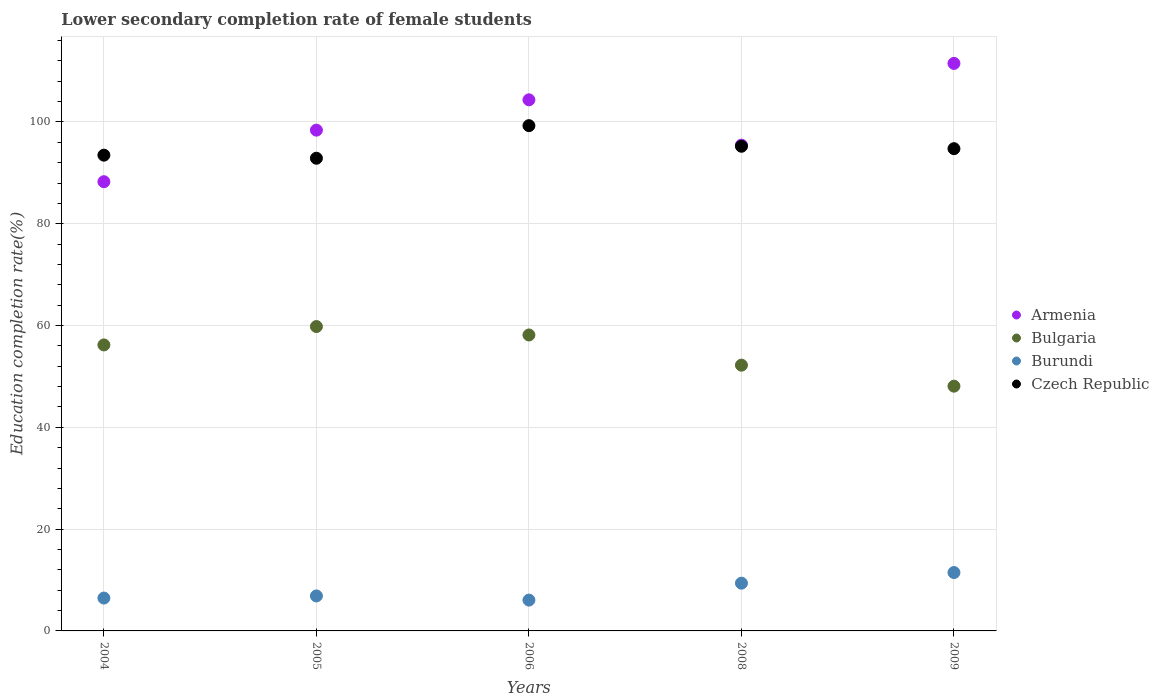What is the lower secondary completion rate of female students in Armenia in 2008?
Offer a very short reply. 95.44. Across all years, what is the maximum lower secondary completion rate of female students in Bulgaria?
Offer a very short reply. 59.8. Across all years, what is the minimum lower secondary completion rate of female students in Armenia?
Give a very brief answer. 88.26. In which year was the lower secondary completion rate of female students in Bulgaria maximum?
Keep it short and to the point. 2005. In which year was the lower secondary completion rate of female students in Bulgaria minimum?
Your answer should be very brief. 2009. What is the total lower secondary completion rate of female students in Burundi in the graph?
Your answer should be very brief. 40.23. What is the difference between the lower secondary completion rate of female students in Burundi in 2006 and that in 2008?
Your answer should be compact. -3.32. What is the difference between the lower secondary completion rate of female students in Burundi in 2006 and the lower secondary completion rate of female students in Czech Republic in 2009?
Your answer should be compact. -88.69. What is the average lower secondary completion rate of female students in Bulgaria per year?
Offer a terse response. 54.89. In the year 2005, what is the difference between the lower secondary completion rate of female students in Czech Republic and lower secondary completion rate of female students in Armenia?
Your answer should be compact. -5.52. What is the ratio of the lower secondary completion rate of female students in Bulgaria in 2004 to that in 2009?
Offer a very short reply. 1.17. Is the lower secondary completion rate of female students in Burundi in 2006 less than that in 2008?
Ensure brevity in your answer.  Yes. What is the difference between the highest and the second highest lower secondary completion rate of female students in Bulgaria?
Your answer should be very brief. 1.65. What is the difference between the highest and the lowest lower secondary completion rate of female students in Czech Republic?
Offer a terse response. 6.4. In how many years, is the lower secondary completion rate of female students in Burundi greater than the average lower secondary completion rate of female students in Burundi taken over all years?
Your answer should be compact. 2. Is it the case that in every year, the sum of the lower secondary completion rate of female students in Bulgaria and lower secondary completion rate of female students in Armenia  is greater than the lower secondary completion rate of female students in Burundi?
Ensure brevity in your answer.  Yes. Does the graph contain grids?
Provide a short and direct response. Yes. Where does the legend appear in the graph?
Offer a very short reply. Center right. What is the title of the graph?
Your response must be concise. Lower secondary completion rate of female students. Does "Dominica" appear as one of the legend labels in the graph?
Provide a short and direct response. No. What is the label or title of the X-axis?
Give a very brief answer. Years. What is the label or title of the Y-axis?
Offer a terse response. Education completion rate(%). What is the Education completion rate(%) of Armenia in 2004?
Ensure brevity in your answer.  88.26. What is the Education completion rate(%) of Bulgaria in 2004?
Provide a succinct answer. 56.19. What is the Education completion rate(%) of Burundi in 2004?
Keep it short and to the point. 6.45. What is the Education completion rate(%) in Czech Republic in 2004?
Provide a succinct answer. 93.48. What is the Education completion rate(%) in Armenia in 2005?
Your answer should be very brief. 98.39. What is the Education completion rate(%) in Bulgaria in 2005?
Give a very brief answer. 59.8. What is the Education completion rate(%) in Burundi in 2005?
Keep it short and to the point. 6.87. What is the Education completion rate(%) of Czech Republic in 2005?
Provide a short and direct response. 92.87. What is the Education completion rate(%) of Armenia in 2006?
Provide a short and direct response. 104.35. What is the Education completion rate(%) in Bulgaria in 2006?
Offer a terse response. 58.14. What is the Education completion rate(%) in Burundi in 2006?
Offer a terse response. 6.06. What is the Education completion rate(%) of Czech Republic in 2006?
Your answer should be very brief. 99.27. What is the Education completion rate(%) of Armenia in 2008?
Provide a short and direct response. 95.44. What is the Education completion rate(%) of Bulgaria in 2008?
Your answer should be compact. 52.21. What is the Education completion rate(%) in Burundi in 2008?
Make the answer very short. 9.38. What is the Education completion rate(%) of Czech Republic in 2008?
Offer a terse response. 95.22. What is the Education completion rate(%) of Armenia in 2009?
Offer a very short reply. 111.5. What is the Education completion rate(%) of Bulgaria in 2009?
Offer a very short reply. 48.09. What is the Education completion rate(%) of Burundi in 2009?
Make the answer very short. 11.47. What is the Education completion rate(%) of Czech Republic in 2009?
Your answer should be compact. 94.75. Across all years, what is the maximum Education completion rate(%) of Armenia?
Offer a terse response. 111.5. Across all years, what is the maximum Education completion rate(%) of Bulgaria?
Your response must be concise. 59.8. Across all years, what is the maximum Education completion rate(%) of Burundi?
Your answer should be compact. 11.47. Across all years, what is the maximum Education completion rate(%) of Czech Republic?
Give a very brief answer. 99.27. Across all years, what is the minimum Education completion rate(%) in Armenia?
Provide a succinct answer. 88.26. Across all years, what is the minimum Education completion rate(%) of Bulgaria?
Give a very brief answer. 48.09. Across all years, what is the minimum Education completion rate(%) in Burundi?
Provide a short and direct response. 6.06. Across all years, what is the minimum Education completion rate(%) of Czech Republic?
Ensure brevity in your answer.  92.87. What is the total Education completion rate(%) of Armenia in the graph?
Your response must be concise. 497.93. What is the total Education completion rate(%) in Bulgaria in the graph?
Your answer should be compact. 274.43. What is the total Education completion rate(%) of Burundi in the graph?
Ensure brevity in your answer.  40.23. What is the total Education completion rate(%) in Czech Republic in the graph?
Keep it short and to the point. 475.59. What is the difference between the Education completion rate(%) in Armenia in 2004 and that in 2005?
Provide a short and direct response. -10.13. What is the difference between the Education completion rate(%) of Bulgaria in 2004 and that in 2005?
Ensure brevity in your answer.  -3.61. What is the difference between the Education completion rate(%) in Burundi in 2004 and that in 2005?
Make the answer very short. -0.42. What is the difference between the Education completion rate(%) in Czech Republic in 2004 and that in 2005?
Offer a terse response. 0.61. What is the difference between the Education completion rate(%) in Armenia in 2004 and that in 2006?
Give a very brief answer. -16.09. What is the difference between the Education completion rate(%) of Bulgaria in 2004 and that in 2006?
Provide a succinct answer. -1.96. What is the difference between the Education completion rate(%) of Burundi in 2004 and that in 2006?
Provide a succinct answer. 0.4. What is the difference between the Education completion rate(%) of Czech Republic in 2004 and that in 2006?
Your answer should be very brief. -5.8. What is the difference between the Education completion rate(%) in Armenia in 2004 and that in 2008?
Keep it short and to the point. -7.18. What is the difference between the Education completion rate(%) of Bulgaria in 2004 and that in 2008?
Ensure brevity in your answer.  3.97. What is the difference between the Education completion rate(%) in Burundi in 2004 and that in 2008?
Your answer should be compact. -2.92. What is the difference between the Education completion rate(%) of Czech Republic in 2004 and that in 2008?
Offer a very short reply. -1.75. What is the difference between the Education completion rate(%) of Armenia in 2004 and that in 2009?
Offer a terse response. -23.24. What is the difference between the Education completion rate(%) in Bulgaria in 2004 and that in 2009?
Give a very brief answer. 8.1. What is the difference between the Education completion rate(%) of Burundi in 2004 and that in 2009?
Your response must be concise. -5.02. What is the difference between the Education completion rate(%) of Czech Republic in 2004 and that in 2009?
Offer a terse response. -1.27. What is the difference between the Education completion rate(%) in Armenia in 2005 and that in 2006?
Offer a terse response. -5.96. What is the difference between the Education completion rate(%) in Bulgaria in 2005 and that in 2006?
Provide a short and direct response. 1.65. What is the difference between the Education completion rate(%) of Burundi in 2005 and that in 2006?
Offer a terse response. 0.82. What is the difference between the Education completion rate(%) in Czech Republic in 2005 and that in 2006?
Provide a short and direct response. -6.4. What is the difference between the Education completion rate(%) of Armenia in 2005 and that in 2008?
Your response must be concise. 2.95. What is the difference between the Education completion rate(%) in Bulgaria in 2005 and that in 2008?
Ensure brevity in your answer.  7.58. What is the difference between the Education completion rate(%) in Burundi in 2005 and that in 2008?
Keep it short and to the point. -2.5. What is the difference between the Education completion rate(%) in Czech Republic in 2005 and that in 2008?
Your answer should be compact. -2.35. What is the difference between the Education completion rate(%) in Armenia in 2005 and that in 2009?
Your answer should be compact. -13.11. What is the difference between the Education completion rate(%) in Bulgaria in 2005 and that in 2009?
Make the answer very short. 11.71. What is the difference between the Education completion rate(%) of Burundi in 2005 and that in 2009?
Your answer should be very brief. -4.6. What is the difference between the Education completion rate(%) in Czech Republic in 2005 and that in 2009?
Offer a terse response. -1.88. What is the difference between the Education completion rate(%) of Armenia in 2006 and that in 2008?
Provide a succinct answer. 8.9. What is the difference between the Education completion rate(%) of Bulgaria in 2006 and that in 2008?
Offer a very short reply. 5.93. What is the difference between the Education completion rate(%) in Burundi in 2006 and that in 2008?
Make the answer very short. -3.32. What is the difference between the Education completion rate(%) in Czech Republic in 2006 and that in 2008?
Ensure brevity in your answer.  4.05. What is the difference between the Education completion rate(%) in Armenia in 2006 and that in 2009?
Your answer should be very brief. -7.15. What is the difference between the Education completion rate(%) in Bulgaria in 2006 and that in 2009?
Provide a short and direct response. 10.06. What is the difference between the Education completion rate(%) in Burundi in 2006 and that in 2009?
Give a very brief answer. -5.41. What is the difference between the Education completion rate(%) of Czech Republic in 2006 and that in 2009?
Offer a very short reply. 4.52. What is the difference between the Education completion rate(%) of Armenia in 2008 and that in 2009?
Ensure brevity in your answer.  -16.06. What is the difference between the Education completion rate(%) of Bulgaria in 2008 and that in 2009?
Your answer should be compact. 4.13. What is the difference between the Education completion rate(%) of Burundi in 2008 and that in 2009?
Offer a terse response. -2.09. What is the difference between the Education completion rate(%) in Czech Republic in 2008 and that in 2009?
Keep it short and to the point. 0.47. What is the difference between the Education completion rate(%) in Armenia in 2004 and the Education completion rate(%) in Bulgaria in 2005?
Your answer should be compact. 28.46. What is the difference between the Education completion rate(%) of Armenia in 2004 and the Education completion rate(%) of Burundi in 2005?
Your response must be concise. 81.38. What is the difference between the Education completion rate(%) of Armenia in 2004 and the Education completion rate(%) of Czech Republic in 2005?
Offer a terse response. -4.61. What is the difference between the Education completion rate(%) in Bulgaria in 2004 and the Education completion rate(%) in Burundi in 2005?
Offer a very short reply. 49.32. What is the difference between the Education completion rate(%) in Bulgaria in 2004 and the Education completion rate(%) in Czech Republic in 2005?
Your answer should be compact. -36.68. What is the difference between the Education completion rate(%) in Burundi in 2004 and the Education completion rate(%) in Czech Republic in 2005?
Offer a terse response. -86.41. What is the difference between the Education completion rate(%) in Armenia in 2004 and the Education completion rate(%) in Bulgaria in 2006?
Keep it short and to the point. 30.11. What is the difference between the Education completion rate(%) in Armenia in 2004 and the Education completion rate(%) in Burundi in 2006?
Offer a very short reply. 82.2. What is the difference between the Education completion rate(%) of Armenia in 2004 and the Education completion rate(%) of Czech Republic in 2006?
Ensure brevity in your answer.  -11.01. What is the difference between the Education completion rate(%) of Bulgaria in 2004 and the Education completion rate(%) of Burundi in 2006?
Your response must be concise. 50.13. What is the difference between the Education completion rate(%) of Bulgaria in 2004 and the Education completion rate(%) of Czech Republic in 2006?
Offer a very short reply. -43.08. What is the difference between the Education completion rate(%) of Burundi in 2004 and the Education completion rate(%) of Czech Republic in 2006?
Your answer should be very brief. -92.82. What is the difference between the Education completion rate(%) in Armenia in 2004 and the Education completion rate(%) in Bulgaria in 2008?
Keep it short and to the point. 36.04. What is the difference between the Education completion rate(%) in Armenia in 2004 and the Education completion rate(%) in Burundi in 2008?
Ensure brevity in your answer.  78.88. What is the difference between the Education completion rate(%) in Armenia in 2004 and the Education completion rate(%) in Czech Republic in 2008?
Your answer should be compact. -6.96. What is the difference between the Education completion rate(%) in Bulgaria in 2004 and the Education completion rate(%) in Burundi in 2008?
Your response must be concise. 46.81. What is the difference between the Education completion rate(%) of Bulgaria in 2004 and the Education completion rate(%) of Czech Republic in 2008?
Your answer should be compact. -39.03. What is the difference between the Education completion rate(%) in Burundi in 2004 and the Education completion rate(%) in Czech Republic in 2008?
Offer a very short reply. -88.77. What is the difference between the Education completion rate(%) in Armenia in 2004 and the Education completion rate(%) in Bulgaria in 2009?
Your response must be concise. 40.17. What is the difference between the Education completion rate(%) in Armenia in 2004 and the Education completion rate(%) in Burundi in 2009?
Provide a succinct answer. 76.79. What is the difference between the Education completion rate(%) of Armenia in 2004 and the Education completion rate(%) of Czech Republic in 2009?
Provide a short and direct response. -6.49. What is the difference between the Education completion rate(%) in Bulgaria in 2004 and the Education completion rate(%) in Burundi in 2009?
Give a very brief answer. 44.72. What is the difference between the Education completion rate(%) of Bulgaria in 2004 and the Education completion rate(%) of Czech Republic in 2009?
Your answer should be very brief. -38.56. What is the difference between the Education completion rate(%) in Burundi in 2004 and the Education completion rate(%) in Czech Republic in 2009?
Give a very brief answer. -88.29. What is the difference between the Education completion rate(%) of Armenia in 2005 and the Education completion rate(%) of Bulgaria in 2006?
Give a very brief answer. 40.24. What is the difference between the Education completion rate(%) in Armenia in 2005 and the Education completion rate(%) in Burundi in 2006?
Provide a succinct answer. 92.33. What is the difference between the Education completion rate(%) of Armenia in 2005 and the Education completion rate(%) of Czech Republic in 2006?
Provide a short and direct response. -0.88. What is the difference between the Education completion rate(%) in Bulgaria in 2005 and the Education completion rate(%) in Burundi in 2006?
Keep it short and to the point. 53.74. What is the difference between the Education completion rate(%) of Bulgaria in 2005 and the Education completion rate(%) of Czech Republic in 2006?
Offer a very short reply. -39.47. What is the difference between the Education completion rate(%) of Burundi in 2005 and the Education completion rate(%) of Czech Republic in 2006?
Your answer should be compact. -92.4. What is the difference between the Education completion rate(%) of Armenia in 2005 and the Education completion rate(%) of Bulgaria in 2008?
Offer a very short reply. 46.17. What is the difference between the Education completion rate(%) in Armenia in 2005 and the Education completion rate(%) in Burundi in 2008?
Your response must be concise. 89.01. What is the difference between the Education completion rate(%) of Armenia in 2005 and the Education completion rate(%) of Czech Republic in 2008?
Your answer should be compact. 3.16. What is the difference between the Education completion rate(%) in Bulgaria in 2005 and the Education completion rate(%) in Burundi in 2008?
Provide a short and direct response. 50.42. What is the difference between the Education completion rate(%) in Bulgaria in 2005 and the Education completion rate(%) in Czech Republic in 2008?
Give a very brief answer. -35.42. What is the difference between the Education completion rate(%) in Burundi in 2005 and the Education completion rate(%) in Czech Republic in 2008?
Keep it short and to the point. -88.35. What is the difference between the Education completion rate(%) of Armenia in 2005 and the Education completion rate(%) of Bulgaria in 2009?
Give a very brief answer. 50.3. What is the difference between the Education completion rate(%) in Armenia in 2005 and the Education completion rate(%) in Burundi in 2009?
Keep it short and to the point. 86.92. What is the difference between the Education completion rate(%) in Armenia in 2005 and the Education completion rate(%) in Czech Republic in 2009?
Your answer should be very brief. 3.64. What is the difference between the Education completion rate(%) of Bulgaria in 2005 and the Education completion rate(%) of Burundi in 2009?
Give a very brief answer. 48.33. What is the difference between the Education completion rate(%) in Bulgaria in 2005 and the Education completion rate(%) in Czech Republic in 2009?
Offer a very short reply. -34.95. What is the difference between the Education completion rate(%) of Burundi in 2005 and the Education completion rate(%) of Czech Republic in 2009?
Keep it short and to the point. -87.87. What is the difference between the Education completion rate(%) in Armenia in 2006 and the Education completion rate(%) in Bulgaria in 2008?
Offer a terse response. 52.13. What is the difference between the Education completion rate(%) of Armenia in 2006 and the Education completion rate(%) of Burundi in 2008?
Make the answer very short. 94.97. What is the difference between the Education completion rate(%) of Armenia in 2006 and the Education completion rate(%) of Czech Republic in 2008?
Your answer should be compact. 9.12. What is the difference between the Education completion rate(%) of Bulgaria in 2006 and the Education completion rate(%) of Burundi in 2008?
Provide a succinct answer. 48.77. What is the difference between the Education completion rate(%) of Bulgaria in 2006 and the Education completion rate(%) of Czech Republic in 2008?
Your answer should be very brief. -37.08. What is the difference between the Education completion rate(%) in Burundi in 2006 and the Education completion rate(%) in Czech Republic in 2008?
Your answer should be very brief. -89.17. What is the difference between the Education completion rate(%) of Armenia in 2006 and the Education completion rate(%) of Bulgaria in 2009?
Ensure brevity in your answer.  56.26. What is the difference between the Education completion rate(%) in Armenia in 2006 and the Education completion rate(%) in Burundi in 2009?
Make the answer very short. 92.88. What is the difference between the Education completion rate(%) in Armenia in 2006 and the Education completion rate(%) in Czech Republic in 2009?
Ensure brevity in your answer.  9.6. What is the difference between the Education completion rate(%) in Bulgaria in 2006 and the Education completion rate(%) in Burundi in 2009?
Provide a succinct answer. 46.67. What is the difference between the Education completion rate(%) of Bulgaria in 2006 and the Education completion rate(%) of Czech Republic in 2009?
Your answer should be very brief. -36.6. What is the difference between the Education completion rate(%) in Burundi in 2006 and the Education completion rate(%) in Czech Republic in 2009?
Your answer should be compact. -88.69. What is the difference between the Education completion rate(%) in Armenia in 2008 and the Education completion rate(%) in Bulgaria in 2009?
Give a very brief answer. 47.35. What is the difference between the Education completion rate(%) in Armenia in 2008 and the Education completion rate(%) in Burundi in 2009?
Keep it short and to the point. 83.97. What is the difference between the Education completion rate(%) of Armenia in 2008 and the Education completion rate(%) of Czech Republic in 2009?
Your response must be concise. 0.69. What is the difference between the Education completion rate(%) in Bulgaria in 2008 and the Education completion rate(%) in Burundi in 2009?
Your answer should be very brief. 40.74. What is the difference between the Education completion rate(%) of Bulgaria in 2008 and the Education completion rate(%) of Czech Republic in 2009?
Make the answer very short. -42.53. What is the difference between the Education completion rate(%) of Burundi in 2008 and the Education completion rate(%) of Czech Republic in 2009?
Your response must be concise. -85.37. What is the average Education completion rate(%) in Armenia per year?
Offer a terse response. 99.59. What is the average Education completion rate(%) in Bulgaria per year?
Your answer should be very brief. 54.89. What is the average Education completion rate(%) in Burundi per year?
Your answer should be compact. 8.05. What is the average Education completion rate(%) of Czech Republic per year?
Give a very brief answer. 95.12. In the year 2004, what is the difference between the Education completion rate(%) of Armenia and Education completion rate(%) of Bulgaria?
Give a very brief answer. 32.07. In the year 2004, what is the difference between the Education completion rate(%) in Armenia and Education completion rate(%) in Burundi?
Provide a short and direct response. 81.8. In the year 2004, what is the difference between the Education completion rate(%) of Armenia and Education completion rate(%) of Czech Republic?
Keep it short and to the point. -5.22. In the year 2004, what is the difference between the Education completion rate(%) in Bulgaria and Education completion rate(%) in Burundi?
Give a very brief answer. 49.73. In the year 2004, what is the difference between the Education completion rate(%) in Bulgaria and Education completion rate(%) in Czech Republic?
Keep it short and to the point. -37.29. In the year 2004, what is the difference between the Education completion rate(%) of Burundi and Education completion rate(%) of Czech Republic?
Offer a very short reply. -87.02. In the year 2005, what is the difference between the Education completion rate(%) in Armenia and Education completion rate(%) in Bulgaria?
Offer a terse response. 38.59. In the year 2005, what is the difference between the Education completion rate(%) in Armenia and Education completion rate(%) in Burundi?
Provide a succinct answer. 91.51. In the year 2005, what is the difference between the Education completion rate(%) of Armenia and Education completion rate(%) of Czech Republic?
Your answer should be compact. 5.52. In the year 2005, what is the difference between the Education completion rate(%) in Bulgaria and Education completion rate(%) in Burundi?
Your response must be concise. 52.93. In the year 2005, what is the difference between the Education completion rate(%) in Bulgaria and Education completion rate(%) in Czech Republic?
Provide a short and direct response. -33.07. In the year 2005, what is the difference between the Education completion rate(%) of Burundi and Education completion rate(%) of Czech Republic?
Your answer should be compact. -85.99. In the year 2006, what is the difference between the Education completion rate(%) of Armenia and Education completion rate(%) of Bulgaria?
Give a very brief answer. 46.2. In the year 2006, what is the difference between the Education completion rate(%) of Armenia and Education completion rate(%) of Burundi?
Provide a short and direct response. 98.29. In the year 2006, what is the difference between the Education completion rate(%) in Armenia and Education completion rate(%) in Czech Republic?
Keep it short and to the point. 5.08. In the year 2006, what is the difference between the Education completion rate(%) in Bulgaria and Education completion rate(%) in Burundi?
Your response must be concise. 52.09. In the year 2006, what is the difference between the Education completion rate(%) of Bulgaria and Education completion rate(%) of Czech Republic?
Your response must be concise. -41.13. In the year 2006, what is the difference between the Education completion rate(%) in Burundi and Education completion rate(%) in Czech Republic?
Ensure brevity in your answer.  -93.21. In the year 2008, what is the difference between the Education completion rate(%) of Armenia and Education completion rate(%) of Bulgaria?
Your answer should be very brief. 43.23. In the year 2008, what is the difference between the Education completion rate(%) of Armenia and Education completion rate(%) of Burundi?
Offer a very short reply. 86.06. In the year 2008, what is the difference between the Education completion rate(%) of Armenia and Education completion rate(%) of Czech Republic?
Provide a succinct answer. 0.22. In the year 2008, what is the difference between the Education completion rate(%) of Bulgaria and Education completion rate(%) of Burundi?
Your answer should be very brief. 42.84. In the year 2008, what is the difference between the Education completion rate(%) in Bulgaria and Education completion rate(%) in Czech Republic?
Provide a succinct answer. -43.01. In the year 2008, what is the difference between the Education completion rate(%) of Burundi and Education completion rate(%) of Czech Republic?
Ensure brevity in your answer.  -85.84. In the year 2009, what is the difference between the Education completion rate(%) in Armenia and Education completion rate(%) in Bulgaria?
Ensure brevity in your answer.  63.41. In the year 2009, what is the difference between the Education completion rate(%) in Armenia and Education completion rate(%) in Burundi?
Make the answer very short. 100.03. In the year 2009, what is the difference between the Education completion rate(%) in Armenia and Education completion rate(%) in Czech Republic?
Ensure brevity in your answer.  16.75. In the year 2009, what is the difference between the Education completion rate(%) in Bulgaria and Education completion rate(%) in Burundi?
Keep it short and to the point. 36.62. In the year 2009, what is the difference between the Education completion rate(%) of Bulgaria and Education completion rate(%) of Czech Republic?
Give a very brief answer. -46.66. In the year 2009, what is the difference between the Education completion rate(%) of Burundi and Education completion rate(%) of Czech Republic?
Keep it short and to the point. -83.28. What is the ratio of the Education completion rate(%) in Armenia in 2004 to that in 2005?
Your answer should be compact. 0.9. What is the ratio of the Education completion rate(%) of Bulgaria in 2004 to that in 2005?
Your answer should be very brief. 0.94. What is the ratio of the Education completion rate(%) in Burundi in 2004 to that in 2005?
Your response must be concise. 0.94. What is the ratio of the Education completion rate(%) of Armenia in 2004 to that in 2006?
Offer a terse response. 0.85. What is the ratio of the Education completion rate(%) in Bulgaria in 2004 to that in 2006?
Offer a very short reply. 0.97. What is the ratio of the Education completion rate(%) of Burundi in 2004 to that in 2006?
Offer a very short reply. 1.07. What is the ratio of the Education completion rate(%) in Czech Republic in 2004 to that in 2006?
Offer a terse response. 0.94. What is the ratio of the Education completion rate(%) in Armenia in 2004 to that in 2008?
Your answer should be compact. 0.92. What is the ratio of the Education completion rate(%) in Bulgaria in 2004 to that in 2008?
Offer a terse response. 1.08. What is the ratio of the Education completion rate(%) in Burundi in 2004 to that in 2008?
Your answer should be compact. 0.69. What is the ratio of the Education completion rate(%) of Czech Republic in 2004 to that in 2008?
Your answer should be compact. 0.98. What is the ratio of the Education completion rate(%) in Armenia in 2004 to that in 2009?
Your answer should be very brief. 0.79. What is the ratio of the Education completion rate(%) of Bulgaria in 2004 to that in 2009?
Ensure brevity in your answer.  1.17. What is the ratio of the Education completion rate(%) of Burundi in 2004 to that in 2009?
Your answer should be very brief. 0.56. What is the ratio of the Education completion rate(%) of Czech Republic in 2004 to that in 2009?
Provide a short and direct response. 0.99. What is the ratio of the Education completion rate(%) of Armenia in 2005 to that in 2006?
Your response must be concise. 0.94. What is the ratio of the Education completion rate(%) of Bulgaria in 2005 to that in 2006?
Ensure brevity in your answer.  1.03. What is the ratio of the Education completion rate(%) in Burundi in 2005 to that in 2006?
Offer a terse response. 1.13. What is the ratio of the Education completion rate(%) of Czech Republic in 2005 to that in 2006?
Keep it short and to the point. 0.94. What is the ratio of the Education completion rate(%) in Armenia in 2005 to that in 2008?
Give a very brief answer. 1.03. What is the ratio of the Education completion rate(%) of Bulgaria in 2005 to that in 2008?
Keep it short and to the point. 1.15. What is the ratio of the Education completion rate(%) in Burundi in 2005 to that in 2008?
Give a very brief answer. 0.73. What is the ratio of the Education completion rate(%) in Czech Republic in 2005 to that in 2008?
Your answer should be compact. 0.98. What is the ratio of the Education completion rate(%) of Armenia in 2005 to that in 2009?
Provide a short and direct response. 0.88. What is the ratio of the Education completion rate(%) in Bulgaria in 2005 to that in 2009?
Provide a succinct answer. 1.24. What is the ratio of the Education completion rate(%) in Burundi in 2005 to that in 2009?
Make the answer very short. 0.6. What is the ratio of the Education completion rate(%) in Czech Republic in 2005 to that in 2009?
Your answer should be very brief. 0.98. What is the ratio of the Education completion rate(%) of Armenia in 2006 to that in 2008?
Your answer should be very brief. 1.09. What is the ratio of the Education completion rate(%) of Bulgaria in 2006 to that in 2008?
Keep it short and to the point. 1.11. What is the ratio of the Education completion rate(%) of Burundi in 2006 to that in 2008?
Make the answer very short. 0.65. What is the ratio of the Education completion rate(%) in Czech Republic in 2006 to that in 2008?
Give a very brief answer. 1.04. What is the ratio of the Education completion rate(%) of Armenia in 2006 to that in 2009?
Provide a succinct answer. 0.94. What is the ratio of the Education completion rate(%) of Bulgaria in 2006 to that in 2009?
Offer a very short reply. 1.21. What is the ratio of the Education completion rate(%) of Burundi in 2006 to that in 2009?
Provide a succinct answer. 0.53. What is the ratio of the Education completion rate(%) of Czech Republic in 2006 to that in 2009?
Your answer should be compact. 1.05. What is the ratio of the Education completion rate(%) in Armenia in 2008 to that in 2009?
Offer a terse response. 0.86. What is the ratio of the Education completion rate(%) in Bulgaria in 2008 to that in 2009?
Provide a succinct answer. 1.09. What is the ratio of the Education completion rate(%) of Burundi in 2008 to that in 2009?
Offer a very short reply. 0.82. What is the ratio of the Education completion rate(%) of Czech Republic in 2008 to that in 2009?
Make the answer very short. 1. What is the difference between the highest and the second highest Education completion rate(%) of Armenia?
Keep it short and to the point. 7.15. What is the difference between the highest and the second highest Education completion rate(%) of Bulgaria?
Provide a succinct answer. 1.65. What is the difference between the highest and the second highest Education completion rate(%) of Burundi?
Provide a succinct answer. 2.09. What is the difference between the highest and the second highest Education completion rate(%) in Czech Republic?
Your answer should be very brief. 4.05. What is the difference between the highest and the lowest Education completion rate(%) of Armenia?
Offer a very short reply. 23.24. What is the difference between the highest and the lowest Education completion rate(%) in Bulgaria?
Provide a short and direct response. 11.71. What is the difference between the highest and the lowest Education completion rate(%) in Burundi?
Your answer should be very brief. 5.41. What is the difference between the highest and the lowest Education completion rate(%) of Czech Republic?
Provide a short and direct response. 6.4. 